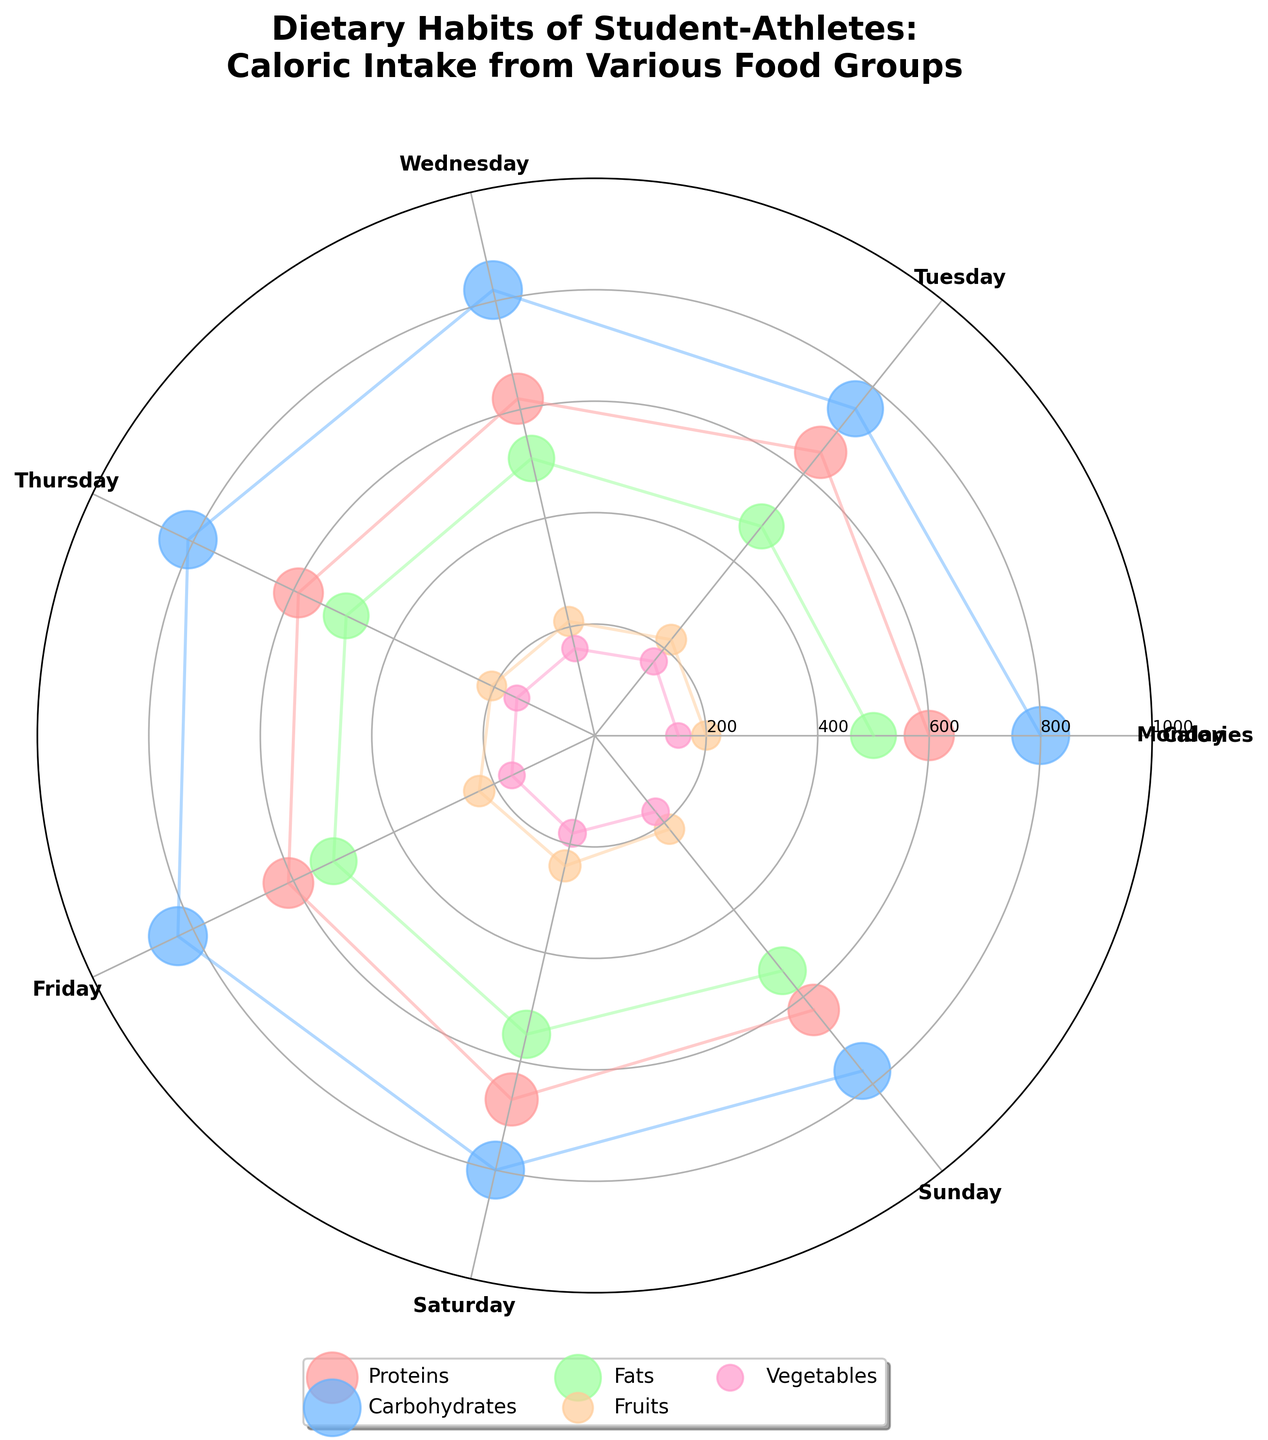What is the title of the chart? The title is usually placed at the top of the chart and is larger in font size. You can easily look at the top section of the Polar Scatter Chart to find it.
Answer: Dietary Habits of Student-Athletes: Caloric Intake from Various Food Groups How many food groups are shown in the chart? Look at the legend at the bottom of the chart where each color represents a different food group. Count the number of unique groups.
Answer: 5 On which day is the highest caloric intake from Carbohydrates observed? Identify the points and lines associated with Carbohydrates, denoted in blue color. Observe the day with the highest radial distance for this color.
Answer: Friday Which food group has the lowest caloric intake on Monday? Look at the point positions for Monday. Compare the radial distances for all food groups on this day and find the one with the smallest distance from the center.
Answer: Vegetables What is the range of caloric intake for Proteins throughout the week? Identify the positions of Proteins throughout the week and note the maximum and minimum radial distances. Subtract the minimum value from the maximum value.
Answer: 670 - 590 = 80 calories Which food group shows the most consistent caloric intake throughout the week? Observe the variation in radial distances for each food group across different days. The group with the least variation is the most consistent.
Answer: Fruits Compare the caloric intake from Fats on Tuesday and Saturday. How much more or less is it on Saturday? Identify the radial distances for Fats on both Tuesday and Saturday. Calculate the difference.
Answer: 550 - 480 = 70 more calories on Saturday What is the total caloric intake from Vegetables for the entire week? Sum the radial distances (caloric values) for Vegetables on each day of the week.
Answer: 150 + 170 + 160 + 155 + 165 + 180 + 175 = 1155 calories Which day has the highest overall caloric intake from all food groups combined? For each day, add the radial distances (caloric values) of all food groups. Compare these sums to find the highest.
Answer: Friday How does the caloric intake from Fats on Sunday compare to Saturday? Identify the radial distances for Fats on both days and check which is higher and by how much.
Answer: 550 - 540 = 10 less calories on Sunday 